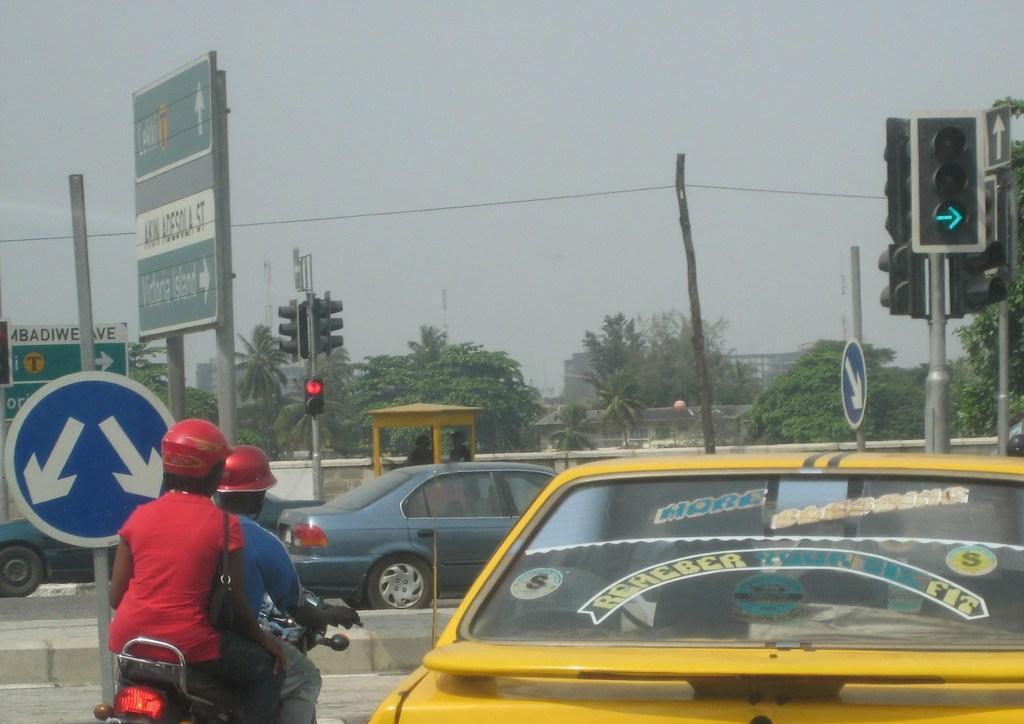In one or two sentences, can you explain what this image depicts? In this picture we can see vehicles on the road. There are people, among them two people riding a bike and wore helmets and we can see boards, traffic signals, wires and poles. In the background of the image we can see trees, buildings and sky. 